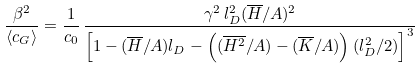Convert formula to latex. <formula><loc_0><loc_0><loc_500><loc_500>\frac { \beta ^ { 2 } } { \langle c _ { G } \rangle } = \frac { 1 } { c _ { 0 } } \, \frac { \gamma ^ { 2 } \, l _ { D } ^ { 2 } ( \overline { H } / A ) ^ { 2 } } { \left [ 1 - ( \overline { H } / A ) l _ { D } - \left ( ( \overline { H ^ { 2 } } / A ) - ( \overline { K } / A ) \right ) ( l _ { D } ^ { 2 } / { 2 } ) \right ] ^ { 3 } }</formula> 